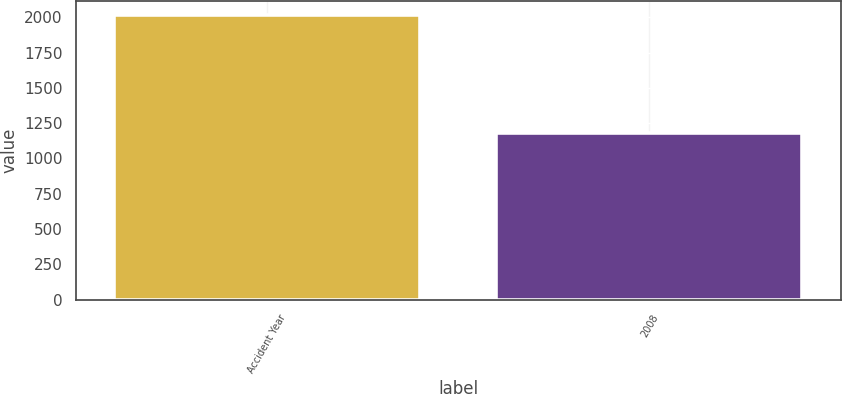<chart> <loc_0><loc_0><loc_500><loc_500><bar_chart><fcel>Accident Year<fcel>2008<nl><fcel>2015<fcel>1183<nl></chart> 